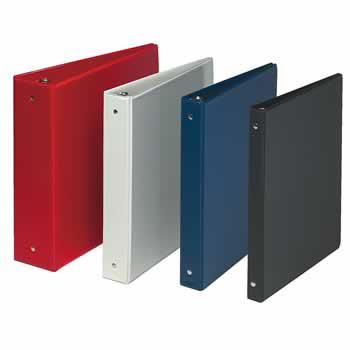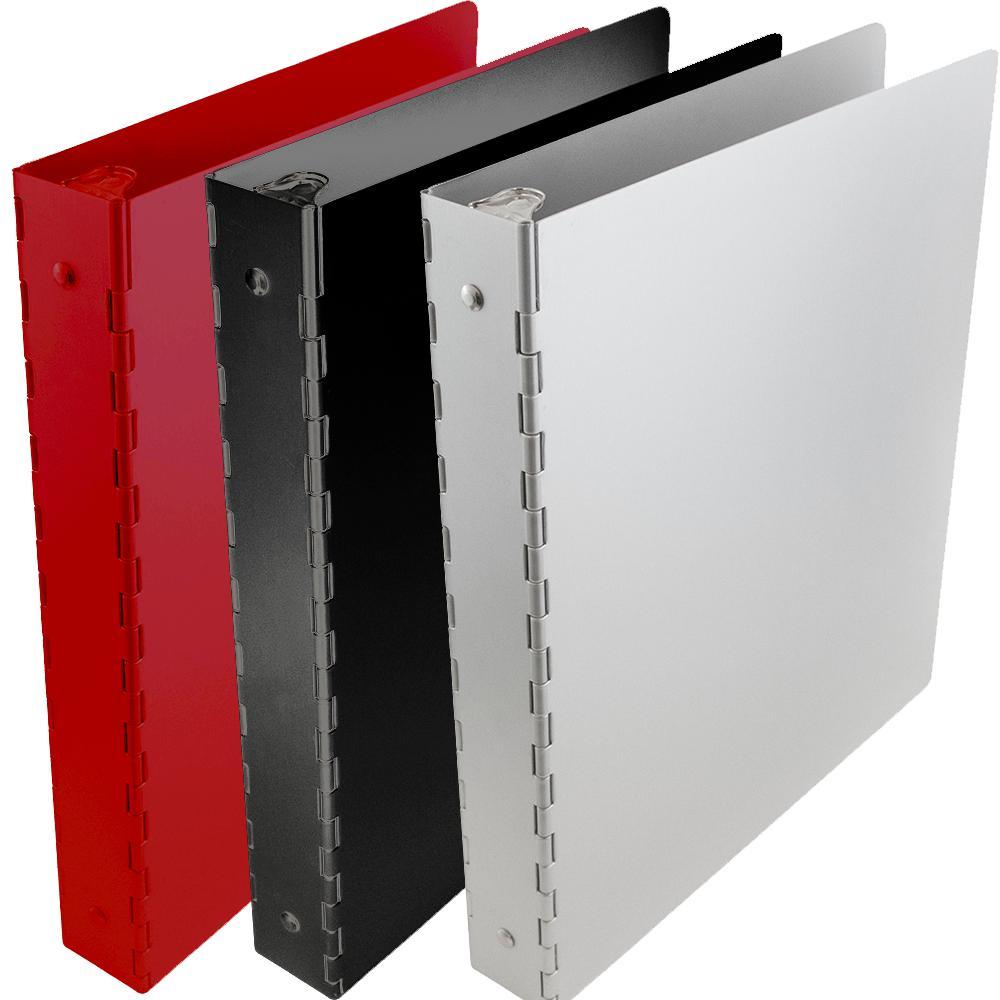The first image is the image on the left, the second image is the image on the right. Considering the images on both sides, is "Here, we see a total of nine binders." valid? Answer yes or no. No. The first image is the image on the left, the second image is the image on the right. Examine the images to the left and right. Is the description "There are exactly nine binders in the pair of images." accurate? Answer yes or no. No. 